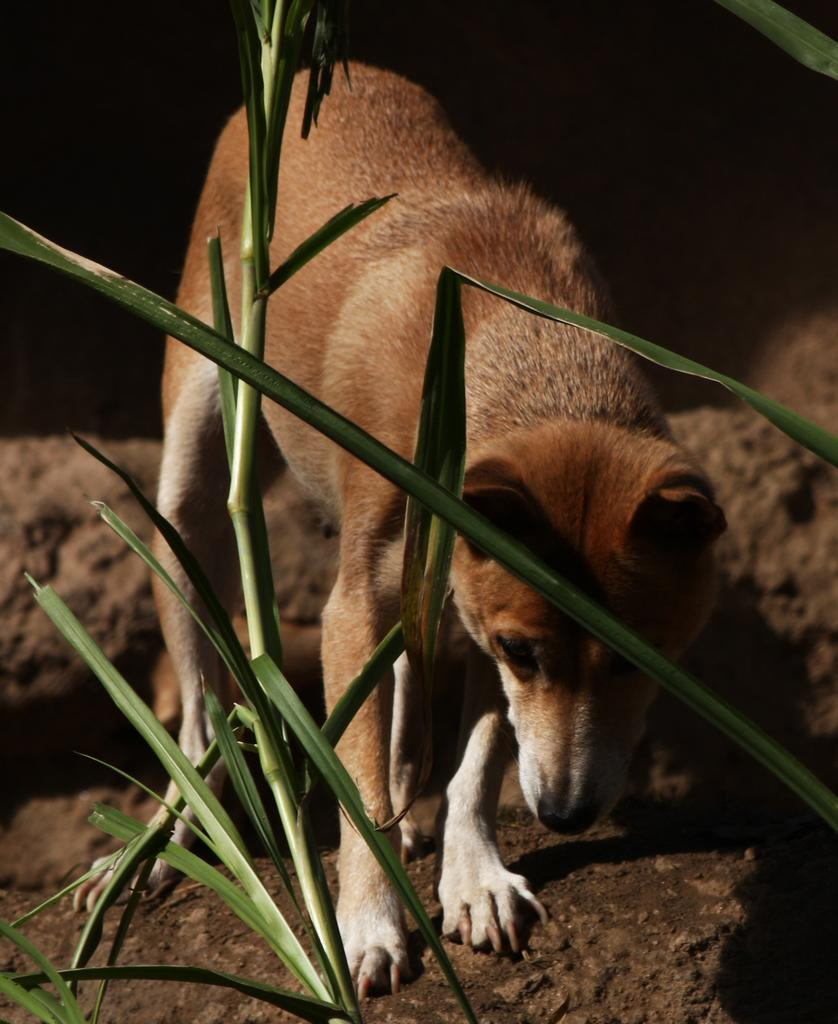What type of living organism can be seen in the image? There is a plant in the image. What other type of living organism can be seen in the image? There is an animal in the image. What is the color of the background in the image? The background of the image is black in color. What type of system is responsible for the volcano eruption in the image? There is no volcano present in the image, so it is not possible to answer that question. 